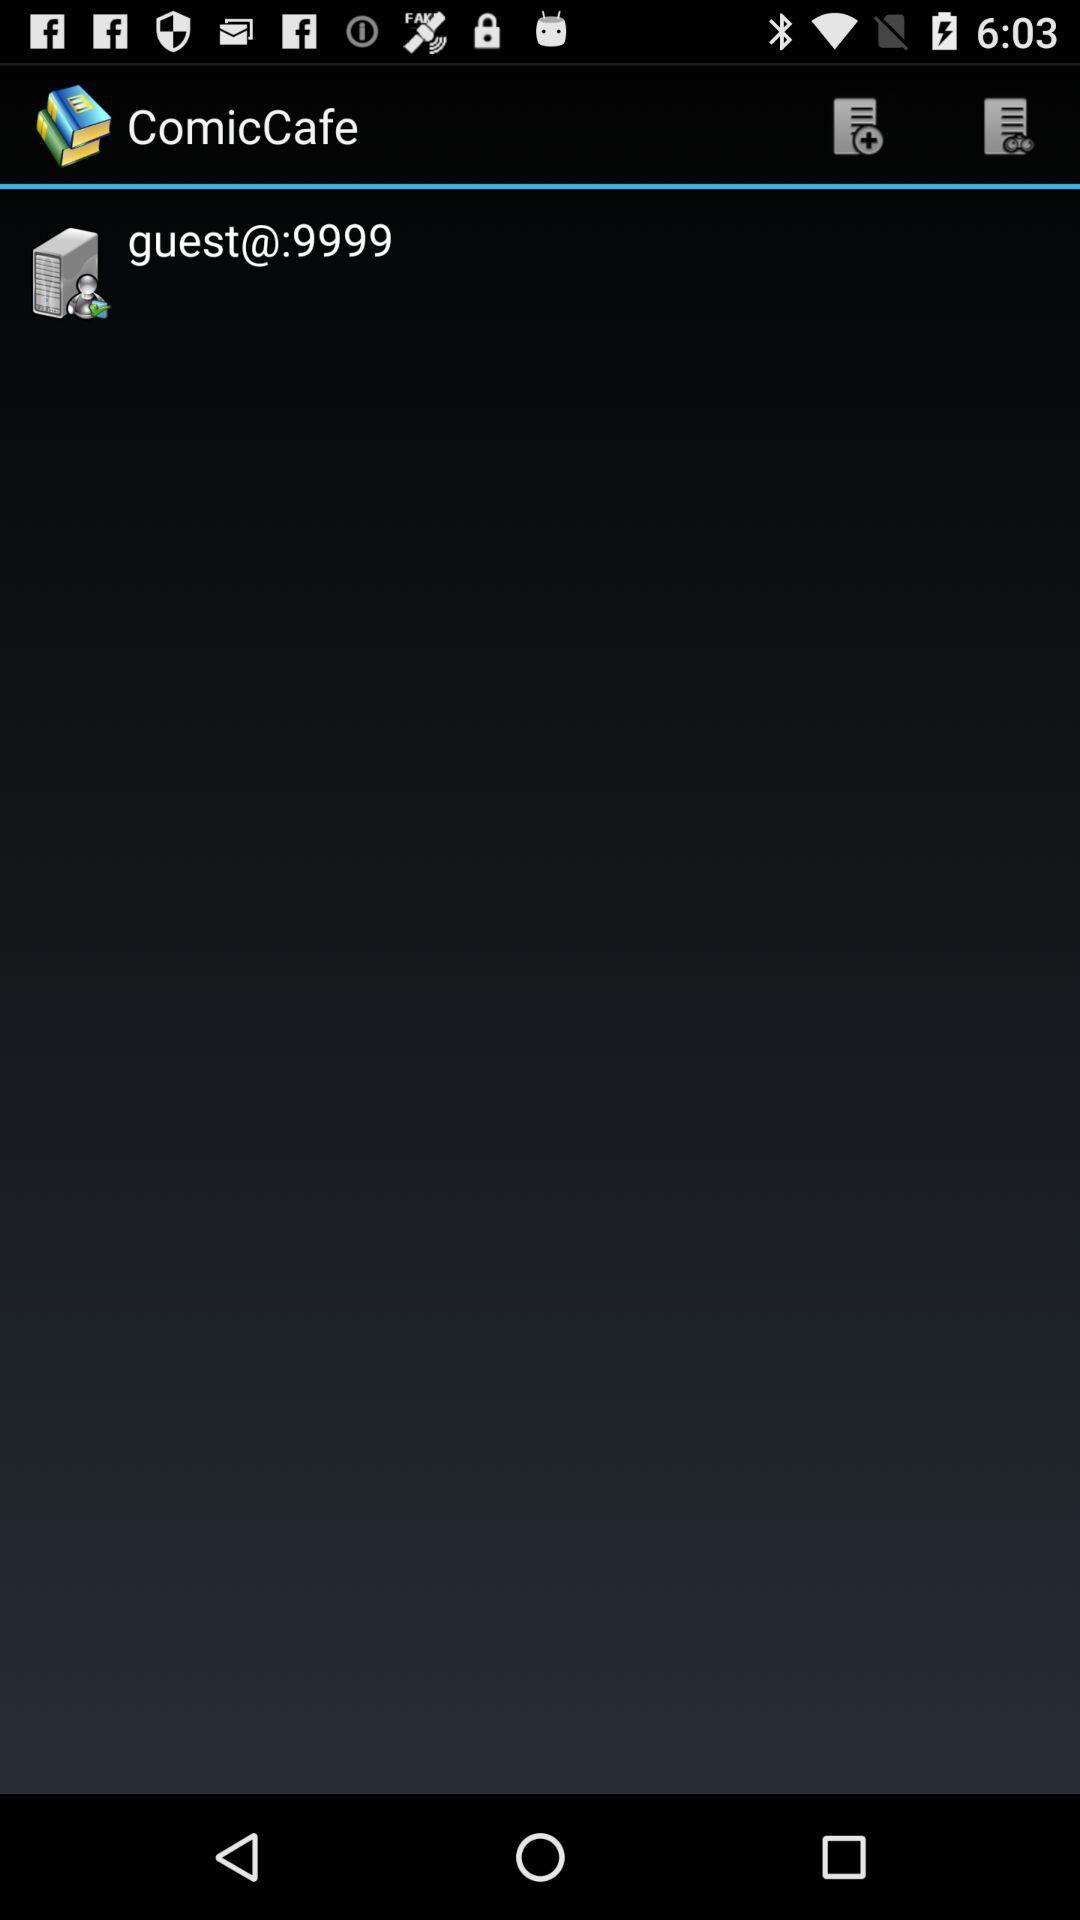What is the username? The username is "guest@". 